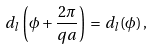<formula> <loc_0><loc_0><loc_500><loc_500>d _ { l } \left ( \phi + \frac { 2 \pi } { q a } \right ) \, = \, d _ { l } ( \phi ) \, ,</formula> 